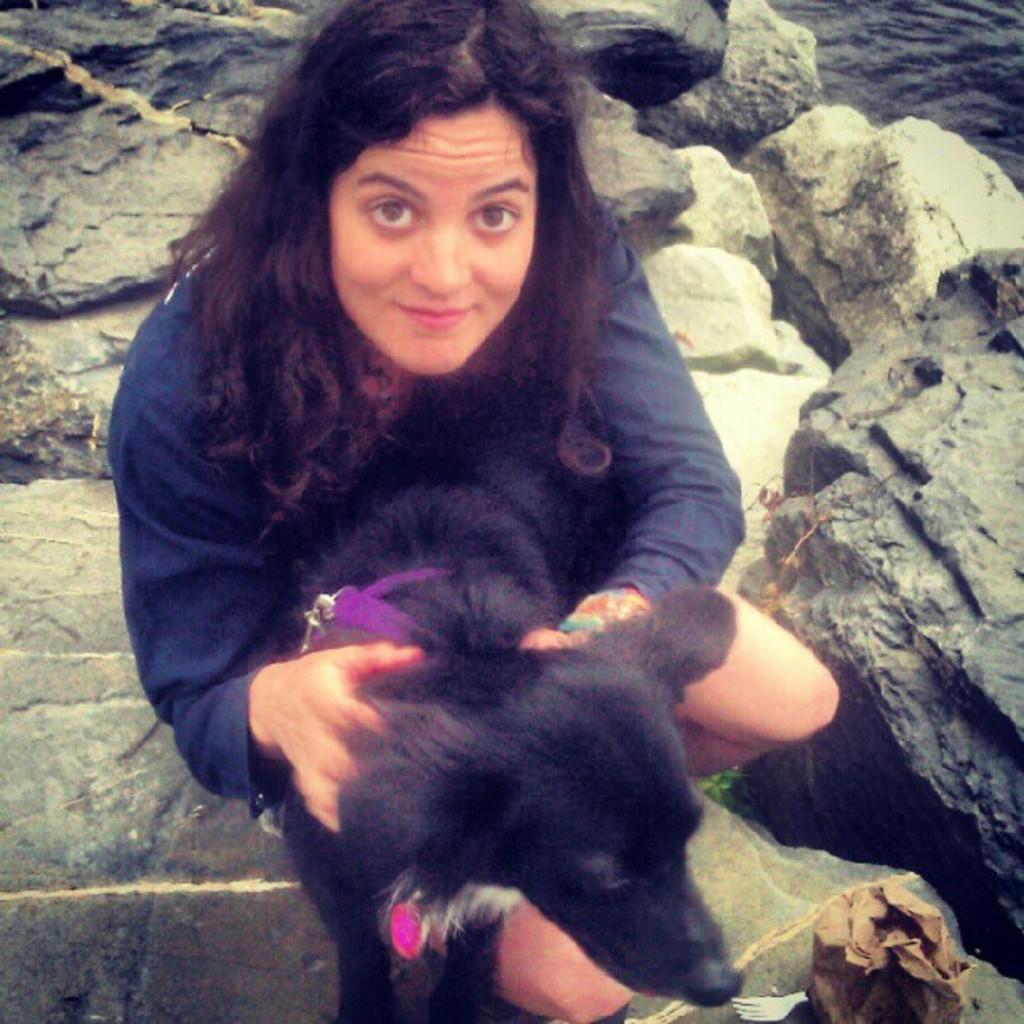Describe this image in one or two sentences. In this image i can see a woman sitting and holding dog at the back ground i can see a rock and water. 